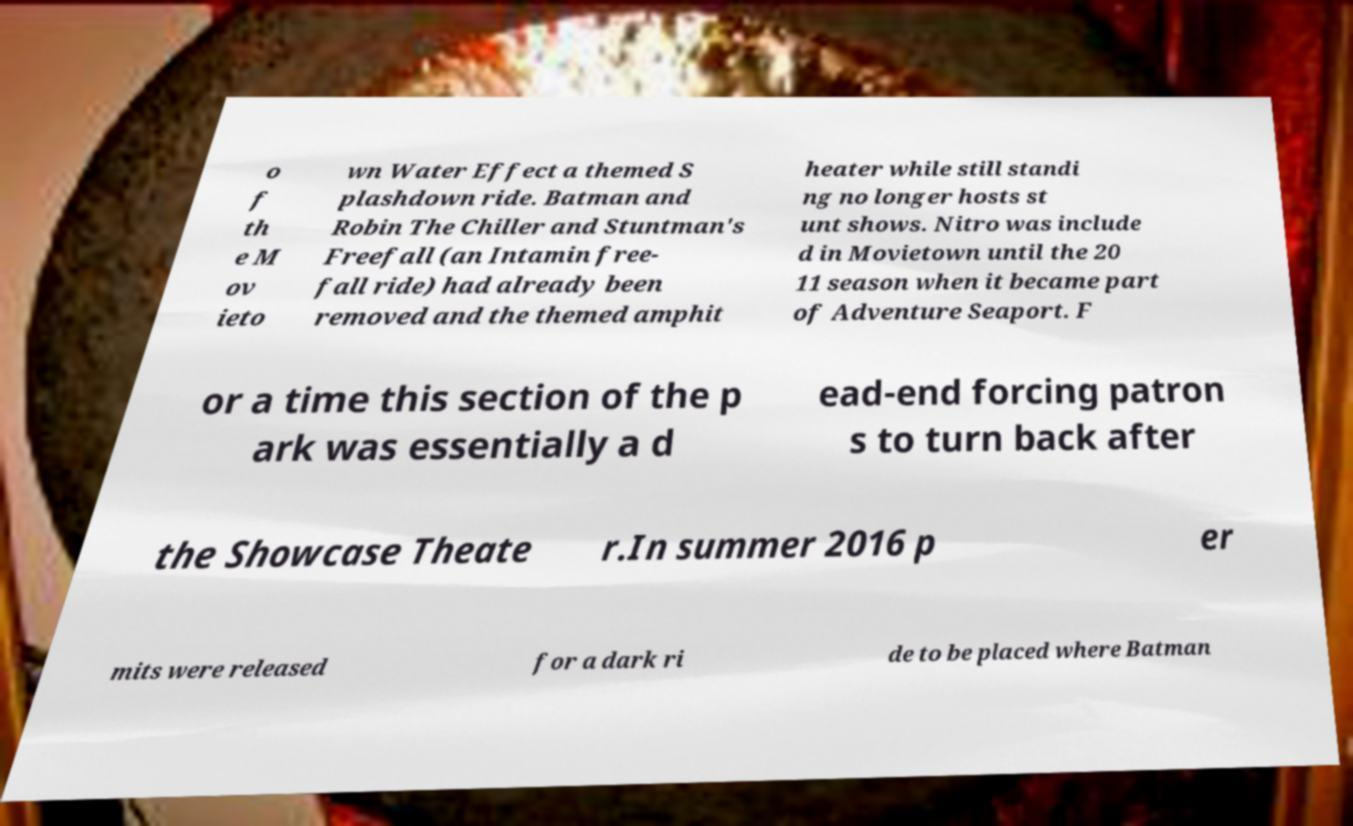Can you read and provide the text displayed in the image?This photo seems to have some interesting text. Can you extract and type it out for me? o f th e M ov ieto wn Water Effect a themed S plashdown ride. Batman and Robin The Chiller and Stuntman's Freefall (an Intamin free- fall ride) had already been removed and the themed amphit heater while still standi ng no longer hosts st unt shows. Nitro was include d in Movietown until the 20 11 season when it became part of Adventure Seaport. F or a time this section of the p ark was essentially a d ead-end forcing patron s to turn back after the Showcase Theate r.In summer 2016 p er mits were released for a dark ri de to be placed where Batman 